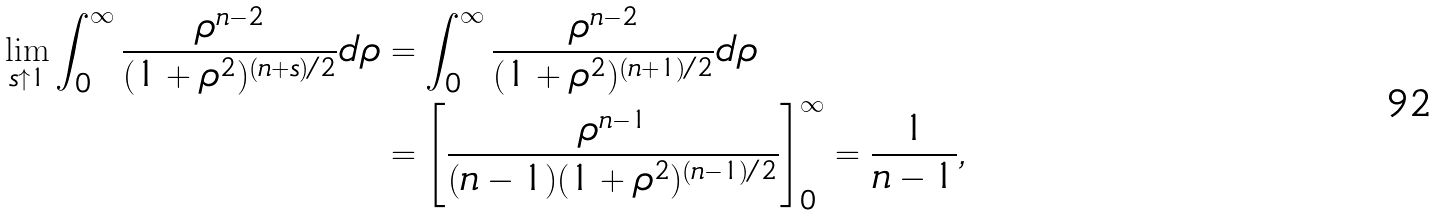Convert formula to latex. <formula><loc_0><loc_0><loc_500><loc_500>\lim _ { s \uparrow 1 } \int _ { 0 } ^ { \infty } \frac { \rho ^ { n - 2 } } { ( 1 + \rho ^ { 2 } ) ^ { ( n + s ) / 2 } } d \rho & = \int _ { 0 } ^ { \infty } \frac { \rho ^ { n - 2 } } { ( 1 + \rho ^ { 2 } ) ^ { ( n + 1 ) / 2 } } d \rho \\ & = \left [ \frac { \rho ^ { n - 1 } } { ( n - 1 ) ( 1 + \rho ^ { 2 } ) ^ { ( n - 1 ) / 2 } } \right ] _ { 0 } ^ { \infty } = \frac { 1 } { n - 1 } ,</formula> 